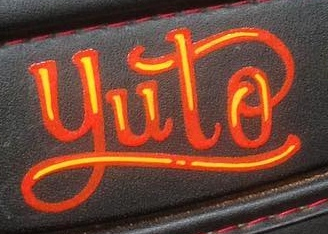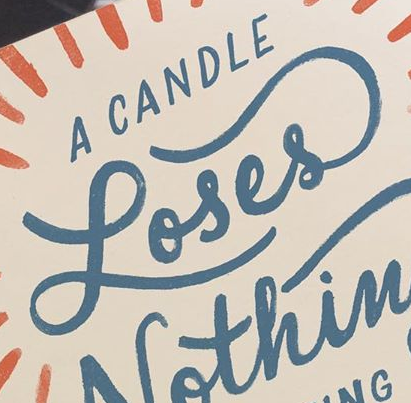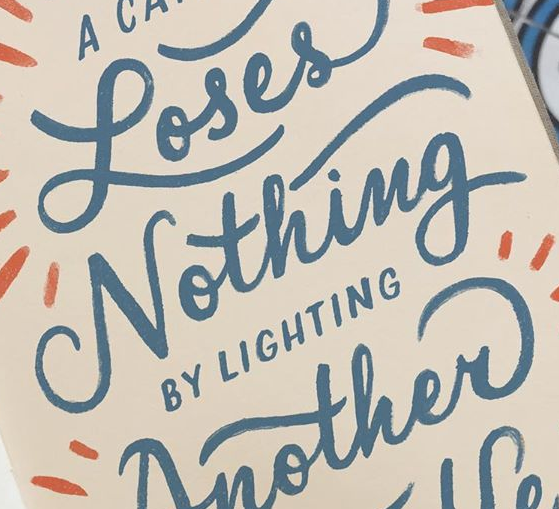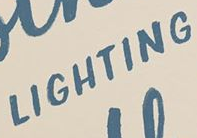Read the text from these images in sequence, separated by a semicolon. yuto; Loses; Nothing; LIGHTING 